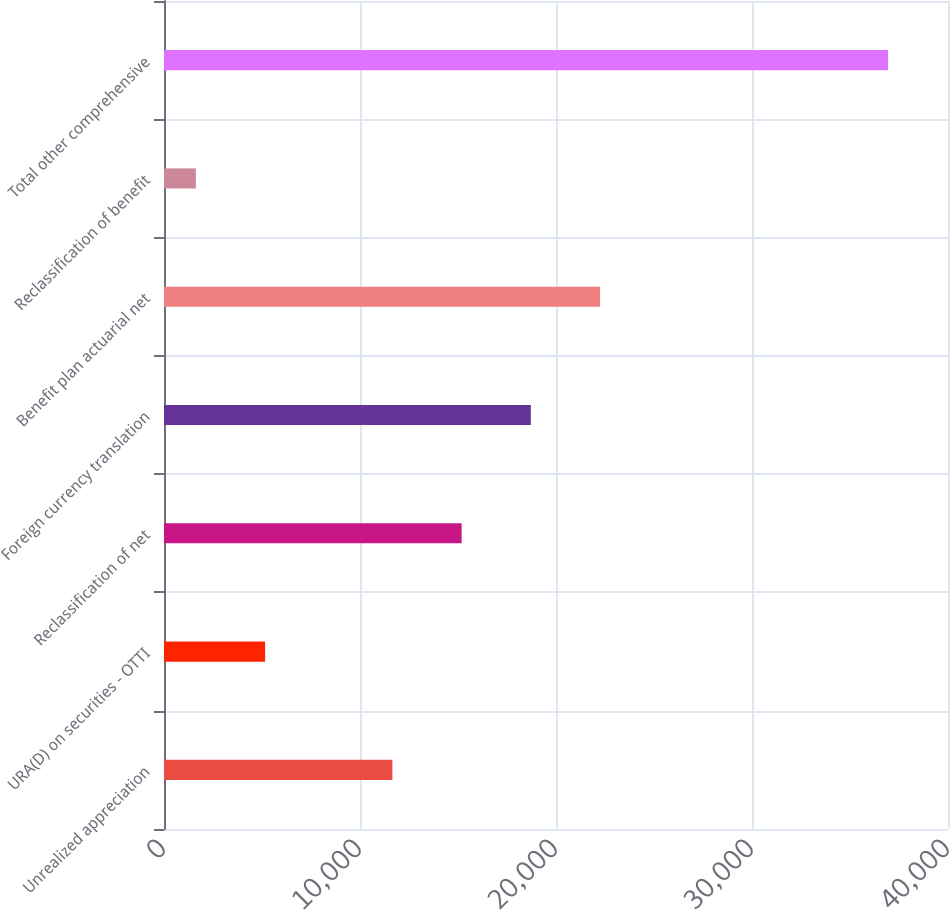<chart> <loc_0><loc_0><loc_500><loc_500><bar_chart><fcel>Unrealized appreciation<fcel>URA(D) on securities - OTTI<fcel>Reclassification of net<fcel>Foreign currency translation<fcel>Benefit plan actuarial net<fcel>Reclassification of benefit<fcel>Total other comprehensive<nl><fcel>11653<fcel>5158.7<fcel>15184.7<fcel>18716.4<fcel>22248.1<fcel>1627<fcel>36944<nl></chart> 